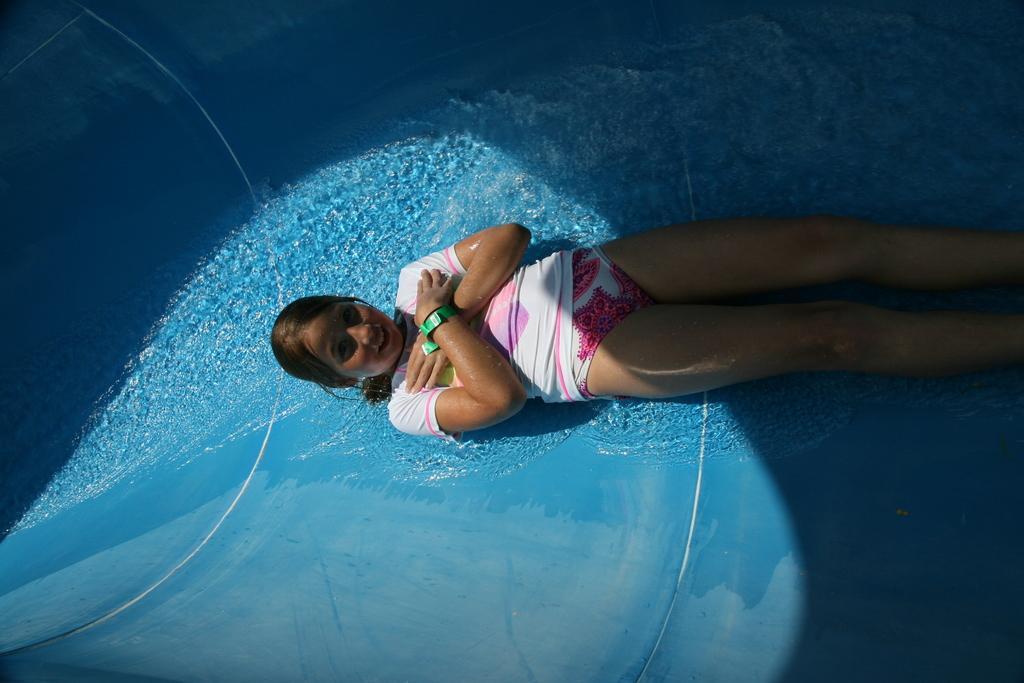Please provide a concise description of this image. In this image, I can see a girl lying and water flowing on the blue surface. 